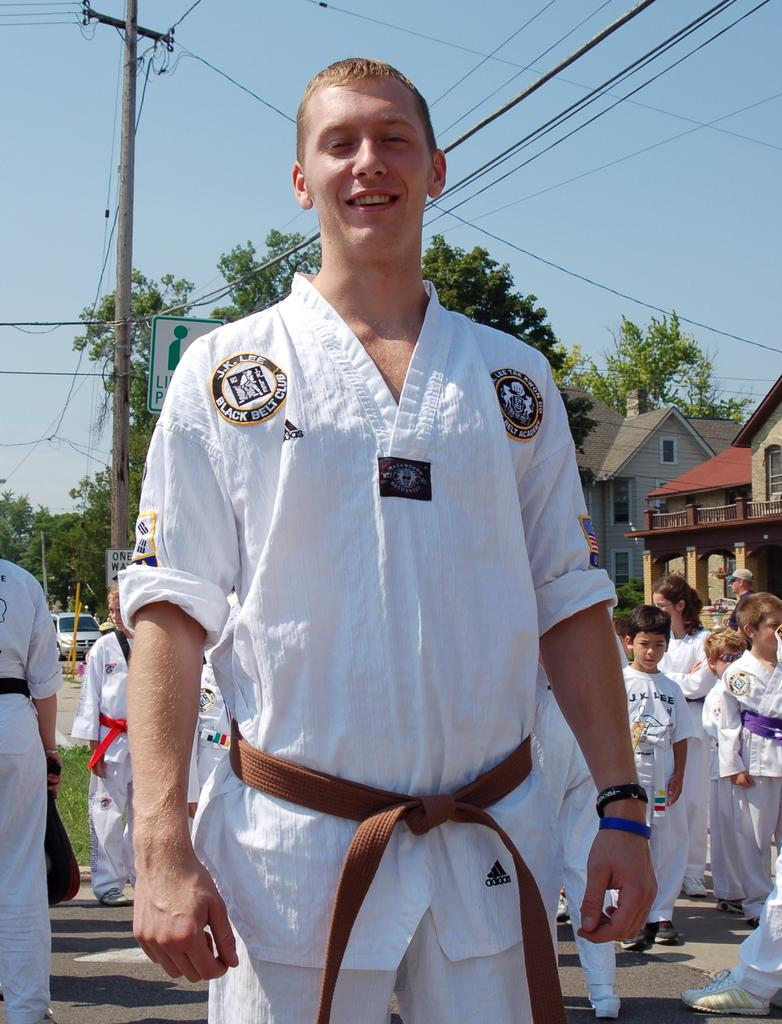<image>
Relay a brief, clear account of the picture shown. the kids are from J. K. Lee Black Belt Club 